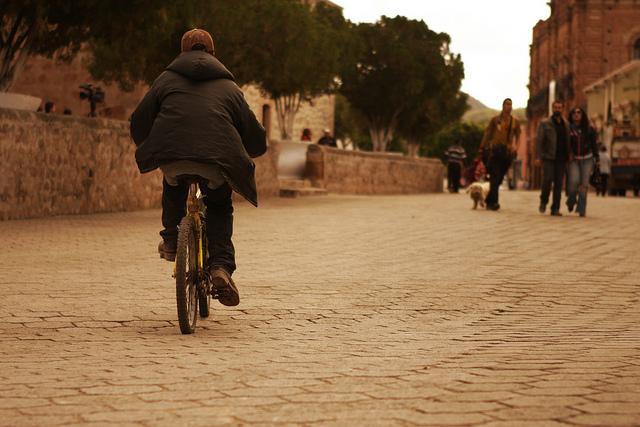What is the pavement made of?
Answer briefly. Bricks. How many bikes are there?
Give a very brief answer. 1. What is the biker wearing on his torso?
Be succinct. Coat. 